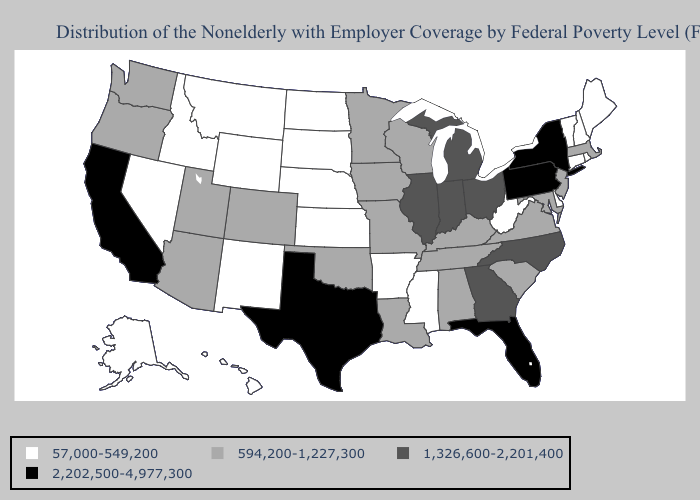What is the value of Kentucky?
Be succinct. 594,200-1,227,300. What is the lowest value in the USA?
Be succinct. 57,000-549,200. Does New York have the highest value in the Northeast?
Quick response, please. Yes. Does Colorado have a lower value than Iowa?
Write a very short answer. No. Does Montana have the highest value in the West?
Be succinct. No. What is the value of Mississippi?
Be succinct. 57,000-549,200. What is the value of Nevada?
Short answer required. 57,000-549,200. Name the states that have a value in the range 594,200-1,227,300?
Be succinct. Alabama, Arizona, Colorado, Iowa, Kentucky, Louisiana, Maryland, Massachusetts, Minnesota, Missouri, New Jersey, Oklahoma, Oregon, South Carolina, Tennessee, Utah, Virginia, Washington, Wisconsin. Does the first symbol in the legend represent the smallest category?
Quick response, please. Yes. What is the value of Michigan?
Concise answer only. 1,326,600-2,201,400. Among the states that border South Carolina , which have the highest value?
Short answer required. Georgia, North Carolina. What is the value of Maryland?
Be succinct. 594,200-1,227,300. What is the lowest value in the USA?
Answer briefly. 57,000-549,200. What is the highest value in states that border Florida?
Be succinct. 1,326,600-2,201,400. What is the highest value in the USA?
Short answer required. 2,202,500-4,977,300. 